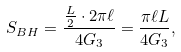<formula> <loc_0><loc_0><loc_500><loc_500>S _ { B H } = \frac { \frac { L } { 2 } \cdot 2 \pi \ell } { 4 G _ { 3 } } = \frac { \pi \ell L } { 4 G _ { 3 } } ,</formula> 